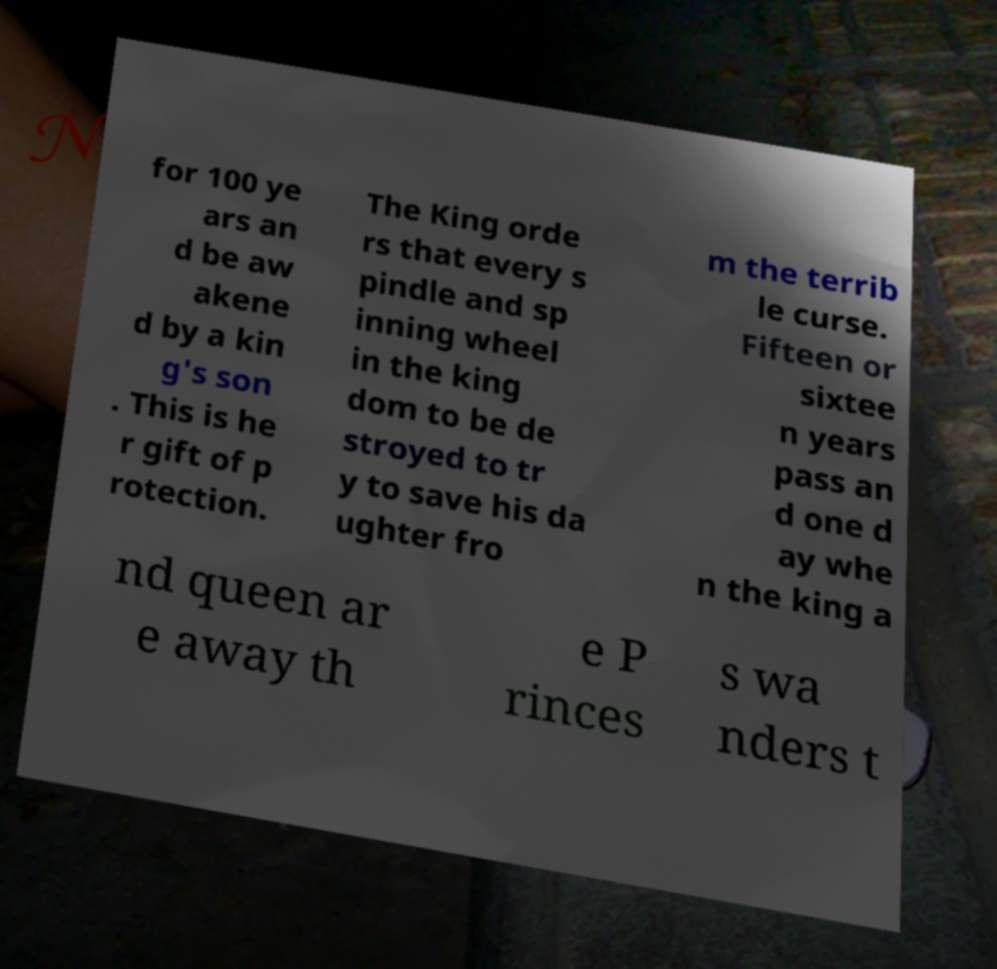Can you read and provide the text displayed in the image?This photo seems to have some interesting text. Can you extract and type it out for me? for 100 ye ars an d be aw akene d by a kin g's son . This is he r gift of p rotection. The King orde rs that every s pindle and sp inning wheel in the king dom to be de stroyed to tr y to save his da ughter fro m the terrib le curse. Fifteen or sixtee n years pass an d one d ay whe n the king a nd queen ar e away th e P rinces s wa nders t 